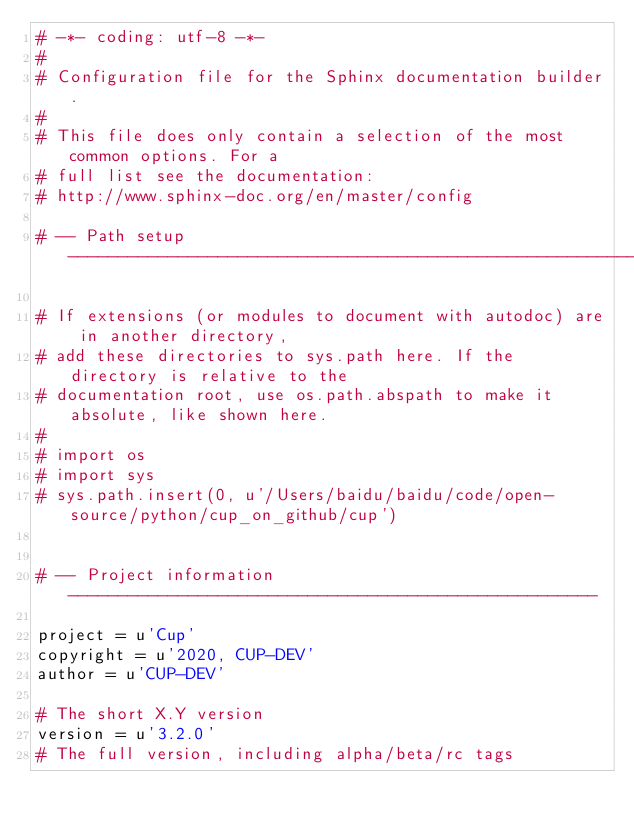Convert code to text. <code><loc_0><loc_0><loc_500><loc_500><_Python_># -*- coding: utf-8 -*-
#
# Configuration file for the Sphinx documentation builder.
#
# This file does only contain a selection of the most common options. For a
# full list see the documentation:
# http://www.sphinx-doc.org/en/master/config

# -- Path setup --------------------------------------------------------------

# If extensions (or modules to document with autodoc) are in another directory,
# add these directories to sys.path here. If the directory is relative to the
# documentation root, use os.path.abspath to make it absolute, like shown here.
#
# import os
# import sys
# sys.path.insert(0, u'/Users/baidu/baidu/code/open-source/python/cup_on_github/cup')


# -- Project information -----------------------------------------------------

project = u'Cup'
copyright = u'2020, CUP-DEV'
author = u'CUP-DEV'

# The short X.Y version
version = u'3.2.0'
# The full version, including alpha/beta/rc tags</code> 